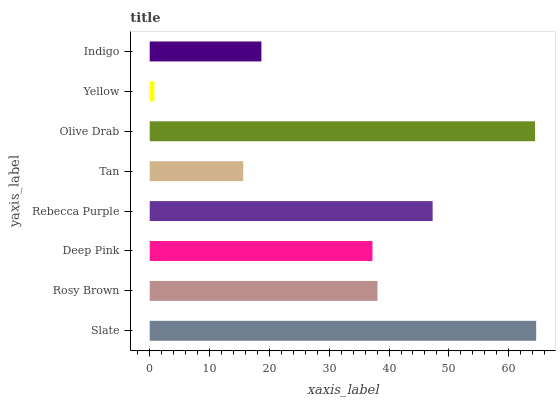Is Yellow the minimum?
Answer yes or no. Yes. Is Slate the maximum?
Answer yes or no. Yes. Is Rosy Brown the minimum?
Answer yes or no. No. Is Rosy Brown the maximum?
Answer yes or no. No. Is Slate greater than Rosy Brown?
Answer yes or no. Yes. Is Rosy Brown less than Slate?
Answer yes or no. Yes. Is Rosy Brown greater than Slate?
Answer yes or no. No. Is Slate less than Rosy Brown?
Answer yes or no. No. Is Rosy Brown the high median?
Answer yes or no. Yes. Is Deep Pink the low median?
Answer yes or no. Yes. Is Indigo the high median?
Answer yes or no. No. Is Rosy Brown the low median?
Answer yes or no. No. 